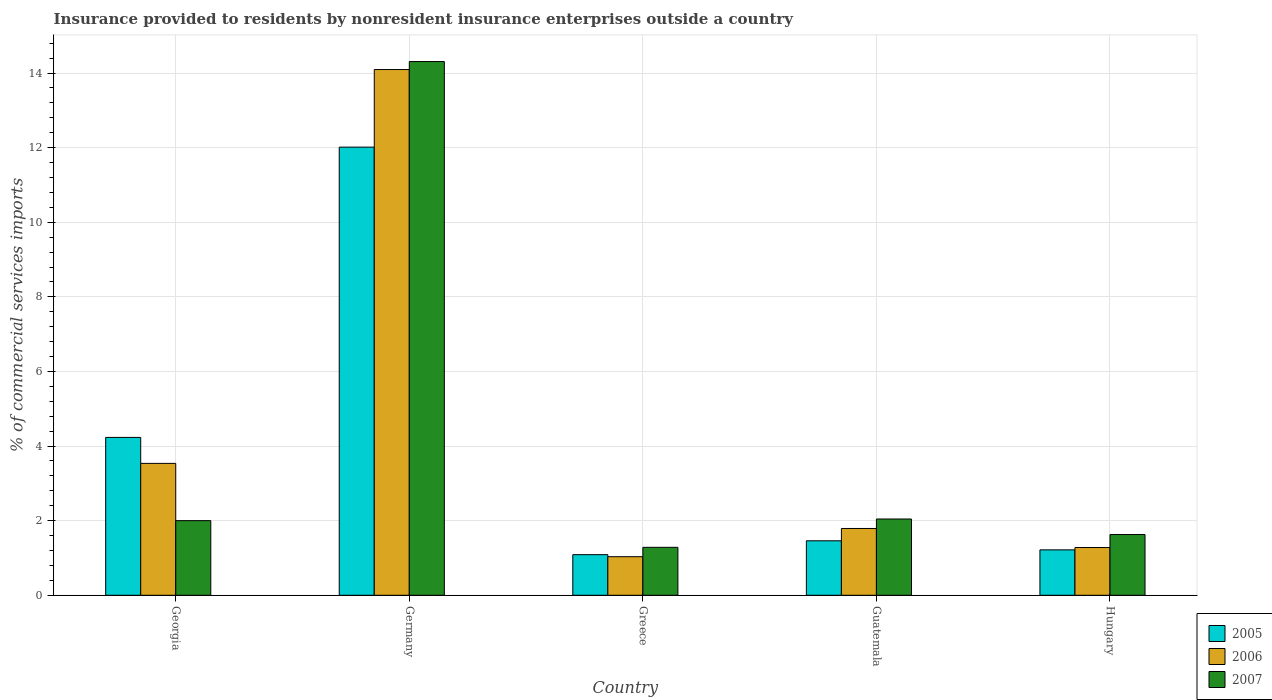How many different coloured bars are there?
Keep it short and to the point. 3. Are the number of bars per tick equal to the number of legend labels?
Give a very brief answer. Yes. How many bars are there on the 3rd tick from the left?
Offer a terse response. 3. How many bars are there on the 3rd tick from the right?
Offer a very short reply. 3. In how many cases, is the number of bars for a given country not equal to the number of legend labels?
Offer a very short reply. 0. What is the Insurance provided to residents in 2007 in Germany?
Provide a short and direct response. 14.31. Across all countries, what is the maximum Insurance provided to residents in 2005?
Provide a short and direct response. 12.01. Across all countries, what is the minimum Insurance provided to residents in 2007?
Give a very brief answer. 1.29. In which country was the Insurance provided to residents in 2005 maximum?
Ensure brevity in your answer.  Germany. In which country was the Insurance provided to residents in 2005 minimum?
Make the answer very short. Greece. What is the total Insurance provided to residents in 2005 in the graph?
Make the answer very short. 20.01. What is the difference between the Insurance provided to residents in 2007 in Georgia and that in Germany?
Ensure brevity in your answer.  -12.31. What is the difference between the Insurance provided to residents in 2006 in Georgia and the Insurance provided to residents in 2005 in Hungary?
Offer a very short reply. 2.32. What is the average Insurance provided to residents in 2007 per country?
Make the answer very short. 4.25. What is the difference between the Insurance provided to residents of/in 2007 and Insurance provided to residents of/in 2006 in Hungary?
Offer a terse response. 0.35. What is the ratio of the Insurance provided to residents in 2005 in Georgia to that in Greece?
Provide a short and direct response. 3.89. Is the Insurance provided to residents in 2007 in Guatemala less than that in Hungary?
Provide a succinct answer. No. Is the difference between the Insurance provided to residents in 2007 in Georgia and Guatemala greater than the difference between the Insurance provided to residents in 2006 in Georgia and Guatemala?
Give a very brief answer. No. What is the difference between the highest and the second highest Insurance provided to residents in 2006?
Ensure brevity in your answer.  -1.74. What is the difference between the highest and the lowest Insurance provided to residents in 2007?
Make the answer very short. 13.02. What does the 3rd bar from the right in Guatemala represents?
Provide a succinct answer. 2005. Is it the case that in every country, the sum of the Insurance provided to residents in 2006 and Insurance provided to residents in 2005 is greater than the Insurance provided to residents in 2007?
Your response must be concise. Yes. How many bars are there?
Your answer should be very brief. 15. Are all the bars in the graph horizontal?
Provide a short and direct response. No. How many countries are there in the graph?
Provide a succinct answer. 5. What is the difference between two consecutive major ticks on the Y-axis?
Your answer should be very brief. 2. Does the graph contain any zero values?
Your answer should be compact. No. How are the legend labels stacked?
Your answer should be compact. Vertical. What is the title of the graph?
Ensure brevity in your answer.  Insurance provided to residents by nonresident insurance enterprises outside a country. What is the label or title of the Y-axis?
Ensure brevity in your answer.  % of commercial services imports. What is the % of commercial services imports in 2005 in Georgia?
Provide a short and direct response. 4.23. What is the % of commercial services imports of 2006 in Georgia?
Make the answer very short. 3.54. What is the % of commercial services imports in 2007 in Georgia?
Keep it short and to the point. 2. What is the % of commercial services imports in 2005 in Germany?
Keep it short and to the point. 12.01. What is the % of commercial services imports in 2006 in Germany?
Keep it short and to the point. 14.09. What is the % of commercial services imports in 2007 in Germany?
Give a very brief answer. 14.31. What is the % of commercial services imports in 2005 in Greece?
Offer a terse response. 1.09. What is the % of commercial services imports in 2006 in Greece?
Your answer should be very brief. 1.03. What is the % of commercial services imports in 2007 in Greece?
Make the answer very short. 1.29. What is the % of commercial services imports in 2005 in Guatemala?
Keep it short and to the point. 1.46. What is the % of commercial services imports in 2006 in Guatemala?
Ensure brevity in your answer.  1.79. What is the % of commercial services imports in 2007 in Guatemala?
Keep it short and to the point. 2.04. What is the % of commercial services imports of 2005 in Hungary?
Your answer should be very brief. 1.22. What is the % of commercial services imports in 2006 in Hungary?
Your answer should be very brief. 1.28. What is the % of commercial services imports in 2007 in Hungary?
Offer a terse response. 1.63. Across all countries, what is the maximum % of commercial services imports in 2005?
Make the answer very short. 12.01. Across all countries, what is the maximum % of commercial services imports of 2006?
Offer a very short reply. 14.09. Across all countries, what is the maximum % of commercial services imports in 2007?
Offer a very short reply. 14.31. Across all countries, what is the minimum % of commercial services imports in 2005?
Make the answer very short. 1.09. Across all countries, what is the minimum % of commercial services imports in 2006?
Offer a terse response. 1.03. Across all countries, what is the minimum % of commercial services imports of 2007?
Ensure brevity in your answer.  1.29. What is the total % of commercial services imports of 2005 in the graph?
Ensure brevity in your answer.  20.01. What is the total % of commercial services imports of 2006 in the graph?
Provide a short and direct response. 21.74. What is the total % of commercial services imports in 2007 in the graph?
Offer a very short reply. 21.27. What is the difference between the % of commercial services imports of 2005 in Georgia and that in Germany?
Provide a short and direct response. -7.78. What is the difference between the % of commercial services imports in 2006 in Georgia and that in Germany?
Your answer should be very brief. -10.56. What is the difference between the % of commercial services imports of 2007 in Georgia and that in Germany?
Your answer should be very brief. -12.31. What is the difference between the % of commercial services imports in 2005 in Georgia and that in Greece?
Provide a succinct answer. 3.14. What is the difference between the % of commercial services imports of 2006 in Georgia and that in Greece?
Offer a terse response. 2.5. What is the difference between the % of commercial services imports in 2007 in Georgia and that in Greece?
Ensure brevity in your answer.  0.72. What is the difference between the % of commercial services imports of 2005 in Georgia and that in Guatemala?
Offer a very short reply. 2.77. What is the difference between the % of commercial services imports of 2006 in Georgia and that in Guatemala?
Offer a very short reply. 1.74. What is the difference between the % of commercial services imports in 2007 in Georgia and that in Guatemala?
Offer a very short reply. -0.04. What is the difference between the % of commercial services imports of 2005 in Georgia and that in Hungary?
Your answer should be compact. 3.01. What is the difference between the % of commercial services imports of 2006 in Georgia and that in Hungary?
Give a very brief answer. 2.26. What is the difference between the % of commercial services imports of 2007 in Georgia and that in Hungary?
Make the answer very short. 0.37. What is the difference between the % of commercial services imports in 2005 in Germany and that in Greece?
Provide a succinct answer. 10.93. What is the difference between the % of commercial services imports of 2006 in Germany and that in Greece?
Keep it short and to the point. 13.06. What is the difference between the % of commercial services imports in 2007 in Germany and that in Greece?
Your answer should be compact. 13.02. What is the difference between the % of commercial services imports of 2005 in Germany and that in Guatemala?
Offer a terse response. 10.55. What is the difference between the % of commercial services imports of 2006 in Germany and that in Guatemala?
Provide a succinct answer. 12.3. What is the difference between the % of commercial services imports in 2007 in Germany and that in Guatemala?
Your response must be concise. 12.26. What is the difference between the % of commercial services imports in 2005 in Germany and that in Hungary?
Ensure brevity in your answer.  10.8. What is the difference between the % of commercial services imports of 2006 in Germany and that in Hungary?
Your answer should be very brief. 12.81. What is the difference between the % of commercial services imports in 2007 in Germany and that in Hungary?
Provide a succinct answer. 12.68. What is the difference between the % of commercial services imports in 2005 in Greece and that in Guatemala?
Provide a succinct answer. -0.37. What is the difference between the % of commercial services imports of 2006 in Greece and that in Guatemala?
Provide a short and direct response. -0.76. What is the difference between the % of commercial services imports in 2007 in Greece and that in Guatemala?
Provide a short and direct response. -0.76. What is the difference between the % of commercial services imports of 2005 in Greece and that in Hungary?
Your answer should be very brief. -0.13. What is the difference between the % of commercial services imports of 2006 in Greece and that in Hungary?
Give a very brief answer. -0.25. What is the difference between the % of commercial services imports of 2007 in Greece and that in Hungary?
Make the answer very short. -0.34. What is the difference between the % of commercial services imports of 2005 in Guatemala and that in Hungary?
Offer a terse response. 0.24. What is the difference between the % of commercial services imports of 2006 in Guatemala and that in Hungary?
Give a very brief answer. 0.51. What is the difference between the % of commercial services imports of 2007 in Guatemala and that in Hungary?
Offer a very short reply. 0.42. What is the difference between the % of commercial services imports in 2005 in Georgia and the % of commercial services imports in 2006 in Germany?
Keep it short and to the point. -9.86. What is the difference between the % of commercial services imports in 2005 in Georgia and the % of commercial services imports in 2007 in Germany?
Keep it short and to the point. -10.08. What is the difference between the % of commercial services imports of 2006 in Georgia and the % of commercial services imports of 2007 in Germany?
Keep it short and to the point. -10.77. What is the difference between the % of commercial services imports in 2005 in Georgia and the % of commercial services imports in 2006 in Greece?
Make the answer very short. 3.2. What is the difference between the % of commercial services imports in 2005 in Georgia and the % of commercial services imports in 2007 in Greece?
Make the answer very short. 2.95. What is the difference between the % of commercial services imports of 2006 in Georgia and the % of commercial services imports of 2007 in Greece?
Provide a short and direct response. 2.25. What is the difference between the % of commercial services imports of 2005 in Georgia and the % of commercial services imports of 2006 in Guatemala?
Ensure brevity in your answer.  2.44. What is the difference between the % of commercial services imports in 2005 in Georgia and the % of commercial services imports in 2007 in Guatemala?
Your answer should be compact. 2.19. What is the difference between the % of commercial services imports in 2006 in Georgia and the % of commercial services imports in 2007 in Guatemala?
Your response must be concise. 1.49. What is the difference between the % of commercial services imports of 2005 in Georgia and the % of commercial services imports of 2006 in Hungary?
Provide a short and direct response. 2.95. What is the difference between the % of commercial services imports in 2005 in Georgia and the % of commercial services imports in 2007 in Hungary?
Ensure brevity in your answer.  2.6. What is the difference between the % of commercial services imports in 2006 in Georgia and the % of commercial services imports in 2007 in Hungary?
Make the answer very short. 1.91. What is the difference between the % of commercial services imports of 2005 in Germany and the % of commercial services imports of 2006 in Greece?
Your response must be concise. 10.98. What is the difference between the % of commercial services imports in 2005 in Germany and the % of commercial services imports in 2007 in Greece?
Give a very brief answer. 10.73. What is the difference between the % of commercial services imports of 2006 in Germany and the % of commercial services imports of 2007 in Greece?
Provide a short and direct response. 12.81. What is the difference between the % of commercial services imports in 2005 in Germany and the % of commercial services imports in 2006 in Guatemala?
Give a very brief answer. 10.22. What is the difference between the % of commercial services imports of 2005 in Germany and the % of commercial services imports of 2007 in Guatemala?
Provide a succinct answer. 9.97. What is the difference between the % of commercial services imports in 2006 in Germany and the % of commercial services imports in 2007 in Guatemala?
Offer a very short reply. 12.05. What is the difference between the % of commercial services imports in 2005 in Germany and the % of commercial services imports in 2006 in Hungary?
Your answer should be compact. 10.73. What is the difference between the % of commercial services imports in 2005 in Germany and the % of commercial services imports in 2007 in Hungary?
Your response must be concise. 10.39. What is the difference between the % of commercial services imports of 2006 in Germany and the % of commercial services imports of 2007 in Hungary?
Your answer should be compact. 12.47. What is the difference between the % of commercial services imports of 2005 in Greece and the % of commercial services imports of 2006 in Guatemala?
Your answer should be very brief. -0.7. What is the difference between the % of commercial services imports in 2005 in Greece and the % of commercial services imports in 2007 in Guatemala?
Ensure brevity in your answer.  -0.96. What is the difference between the % of commercial services imports of 2006 in Greece and the % of commercial services imports of 2007 in Guatemala?
Offer a terse response. -1.01. What is the difference between the % of commercial services imports of 2005 in Greece and the % of commercial services imports of 2006 in Hungary?
Keep it short and to the point. -0.19. What is the difference between the % of commercial services imports of 2005 in Greece and the % of commercial services imports of 2007 in Hungary?
Provide a short and direct response. -0.54. What is the difference between the % of commercial services imports in 2006 in Greece and the % of commercial services imports in 2007 in Hungary?
Keep it short and to the point. -0.59. What is the difference between the % of commercial services imports of 2005 in Guatemala and the % of commercial services imports of 2006 in Hungary?
Your answer should be compact. 0.18. What is the difference between the % of commercial services imports of 2005 in Guatemala and the % of commercial services imports of 2007 in Hungary?
Give a very brief answer. -0.17. What is the difference between the % of commercial services imports in 2006 in Guatemala and the % of commercial services imports in 2007 in Hungary?
Ensure brevity in your answer.  0.16. What is the average % of commercial services imports in 2005 per country?
Provide a succinct answer. 4. What is the average % of commercial services imports of 2006 per country?
Your response must be concise. 4.35. What is the average % of commercial services imports in 2007 per country?
Your response must be concise. 4.25. What is the difference between the % of commercial services imports in 2005 and % of commercial services imports in 2006 in Georgia?
Your response must be concise. 0.7. What is the difference between the % of commercial services imports in 2005 and % of commercial services imports in 2007 in Georgia?
Provide a succinct answer. 2.23. What is the difference between the % of commercial services imports in 2006 and % of commercial services imports in 2007 in Georgia?
Give a very brief answer. 1.53. What is the difference between the % of commercial services imports of 2005 and % of commercial services imports of 2006 in Germany?
Offer a very short reply. -2.08. What is the difference between the % of commercial services imports in 2005 and % of commercial services imports in 2007 in Germany?
Offer a terse response. -2.29. What is the difference between the % of commercial services imports of 2006 and % of commercial services imports of 2007 in Germany?
Make the answer very short. -0.21. What is the difference between the % of commercial services imports of 2005 and % of commercial services imports of 2006 in Greece?
Your response must be concise. 0.05. What is the difference between the % of commercial services imports in 2005 and % of commercial services imports in 2007 in Greece?
Offer a very short reply. -0.2. What is the difference between the % of commercial services imports of 2006 and % of commercial services imports of 2007 in Greece?
Give a very brief answer. -0.25. What is the difference between the % of commercial services imports in 2005 and % of commercial services imports in 2006 in Guatemala?
Make the answer very short. -0.33. What is the difference between the % of commercial services imports in 2005 and % of commercial services imports in 2007 in Guatemala?
Give a very brief answer. -0.58. What is the difference between the % of commercial services imports in 2006 and % of commercial services imports in 2007 in Guatemala?
Your answer should be compact. -0.25. What is the difference between the % of commercial services imports in 2005 and % of commercial services imports in 2006 in Hungary?
Ensure brevity in your answer.  -0.06. What is the difference between the % of commercial services imports of 2005 and % of commercial services imports of 2007 in Hungary?
Offer a very short reply. -0.41. What is the difference between the % of commercial services imports in 2006 and % of commercial services imports in 2007 in Hungary?
Your answer should be very brief. -0.35. What is the ratio of the % of commercial services imports of 2005 in Georgia to that in Germany?
Offer a very short reply. 0.35. What is the ratio of the % of commercial services imports in 2006 in Georgia to that in Germany?
Give a very brief answer. 0.25. What is the ratio of the % of commercial services imports in 2007 in Georgia to that in Germany?
Keep it short and to the point. 0.14. What is the ratio of the % of commercial services imports of 2005 in Georgia to that in Greece?
Your answer should be compact. 3.89. What is the ratio of the % of commercial services imports in 2006 in Georgia to that in Greece?
Your answer should be very brief. 3.42. What is the ratio of the % of commercial services imports of 2007 in Georgia to that in Greece?
Provide a succinct answer. 1.56. What is the ratio of the % of commercial services imports of 2005 in Georgia to that in Guatemala?
Provide a short and direct response. 2.9. What is the ratio of the % of commercial services imports of 2006 in Georgia to that in Guatemala?
Make the answer very short. 1.97. What is the ratio of the % of commercial services imports in 2007 in Georgia to that in Guatemala?
Give a very brief answer. 0.98. What is the ratio of the % of commercial services imports of 2005 in Georgia to that in Hungary?
Offer a very short reply. 3.48. What is the ratio of the % of commercial services imports of 2006 in Georgia to that in Hungary?
Your response must be concise. 2.76. What is the ratio of the % of commercial services imports of 2007 in Georgia to that in Hungary?
Your response must be concise. 1.23. What is the ratio of the % of commercial services imports in 2005 in Germany to that in Greece?
Your answer should be compact. 11.03. What is the ratio of the % of commercial services imports in 2006 in Germany to that in Greece?
Offer a very short reply. 13.63. What is the ratio of the % of commercial services imports in 2007 in Germany to that in Greece?
Provide a short and direct response. 11.13. What is the ratio of the % of commercial services imports of 2005 in Germany to that in Guatemala?
Provide a succinct answer. 8.23. What is the ratio of the % of commercial services imports of 2006 in Germany to that in Guatemala?
Your answer should be very brief. 7.87. What is the ratio of the % of commercial services imports of 2007 in Germany to that in Guatemala?
Ensure brevity in your answer.  7. What is the ratio of the % of commercial services imports in 2005 in Germany to that in Hungary?
Offer a terse response. 9.87. What is the ratio of the % of commercial services imports of 2006 in Germany to that in Hungary?
Offer a terse response. 11.01. What is the ratio of the % of commercial services imports in 2007 in Germany to that in Hungary?
Provide a short and direct response. 8.79. What is the ratio of the % of commercial services imports in 2005 in Greece to that in Guatemala?
Provide a short and direct response. 0.75. What is the ratio of the % of commercial services imports of 2006 in Greece to that in Guatemala?
Offer a very short reply. 0.58. What is the ratio of the % of commercial services imports of 2007 in Greece to that in Guatemala?
Give a very brief answer. 0.63. What is the ratio of the % of commercial services imports of 2005 in Greece to that in Hungary?
Make the answer very short. 0.89. What is the ratio of the % of commercial services imports in 2006 in Greece to that in Hungary?
Your response must be concise. 0.81. What is the ratio of the % of commercial services imports of 2007 in Greece to that in Hungary?
Your response must be concise. 0.79. What is the ratio of the % of commercial services imports of 2005 in Guatemala to that in Hungary?
Make the answer very short. 1.2. What is the ratio of the % of commercial services imports of 2006 in Guatemala to that in Hungary?
Provide a succinct answer. 1.4. What is the ratio of the % of commercial services imports in 2007 in Guatemala to that in Hungary?
Make the answer very short. 1.26. What is the difference between the highest and the second highest % of commercial services imports in 2005?
Ensure brevity in your answer.  7.78. What is the difference between the highest and the second highest % of commercial services imports of 2006?
Your response must be concise. 10.56. What is the difference between the highest and the second highest % of commercial services imports in 2007?
Offer a terse response. 12.26. What is the difference between the highest and the lowest % of commercial services imports in 2005?
Offer a terse response. 10.93. What is the difference between the highest and the lowest % of commercial services imports in 2006?
Offer a very short reply. 13.06. What is the difference between the highest and the lowest % of commercial services imports of 2007?
Provide a succinct answer. 13.02. 